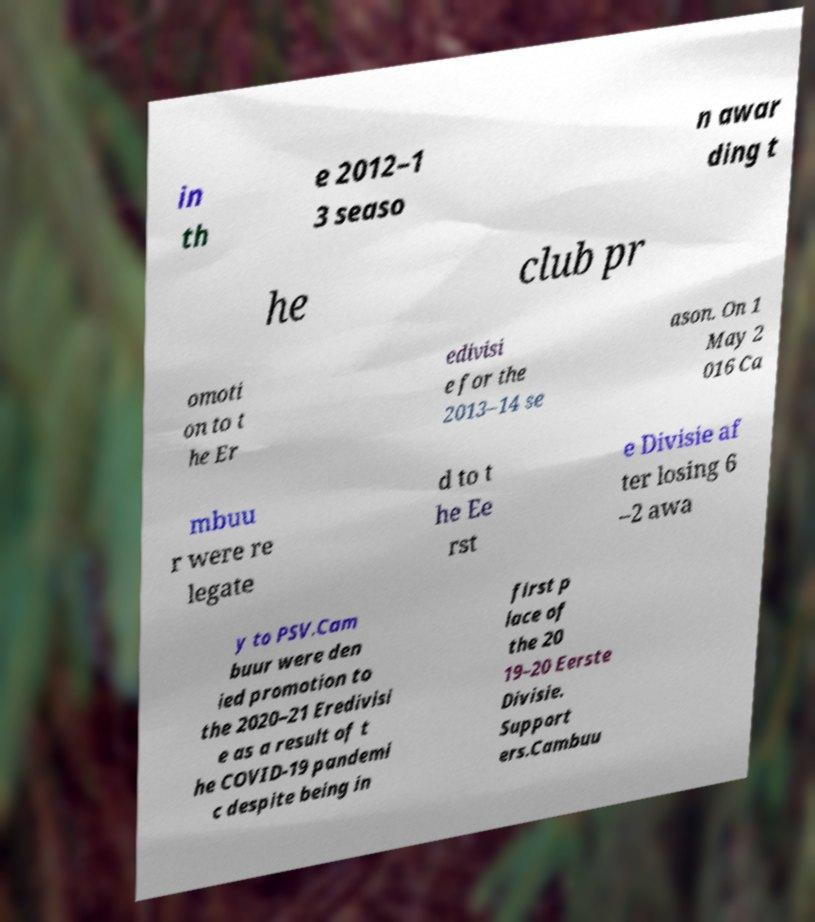Can you read and provide the text displayed in the image?This photo seems to have some interesting text. Can you extract and type it out for me? in th e 2012–1 3 seaso n awar ding t he club pr omoti on to t he Er edivisi e for the 2013–14 se ason. On 1 May 2 016 Ca mbuu r were re legate d to t he Ee rst e Divisie af ter losing 6 –2 awa y to PSV.Cam buur were den ied promotion to the 2020–21 Eredivisi e as a result of t he COVID-19 pandemi c despite being in first p lace of the 20 19–20 Eerste Divisie. Support ers.Cambuu 